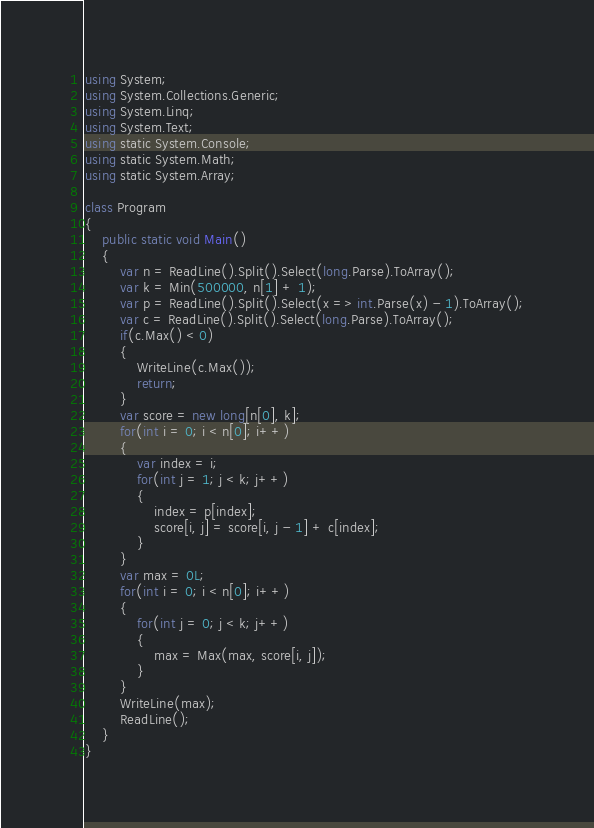<code> <loc_0><loc_0><loc_500><loc_500><_C#_>using System;
using System.Collections.Generic;
using System.Linq;
using System.Text;
using static System.Console;
using static System.Math;
using static System.Array;

class Program
{
	public static void Main()
	{
		var n = ReadLine().Split().Select(long.Parse).ToArray();
		var k = Min(500000, n[1] + 1);
		var p = ReadLine().Split().Select(x => int.Parse(x) - 1).ToArray();
		var c = ReadLine().Split().Select(long.Parse).ToArray();
		if(c.Max() < 0)
		{
			WriteLine(c.Max());
			return;
		}
		var score = new long[n[0], k];
		for(int i = 0; i < n[0]; i++)
		{
			var index = i;
			for(int j = 1; j < k; j++)
			{
				index = p[index];
				score[i, j] = score[i, j - 1] + c[index];
			}
		}
		var max = 0L;
		for(int i = 0; i < n[0]; i++)
		{
			for(int j = 0; j < k; j++)
			{
				max = Max(max, score[i, j]);
			}
		}
		WriteLine(max);
		ReadLine();
	}
}
</code> 